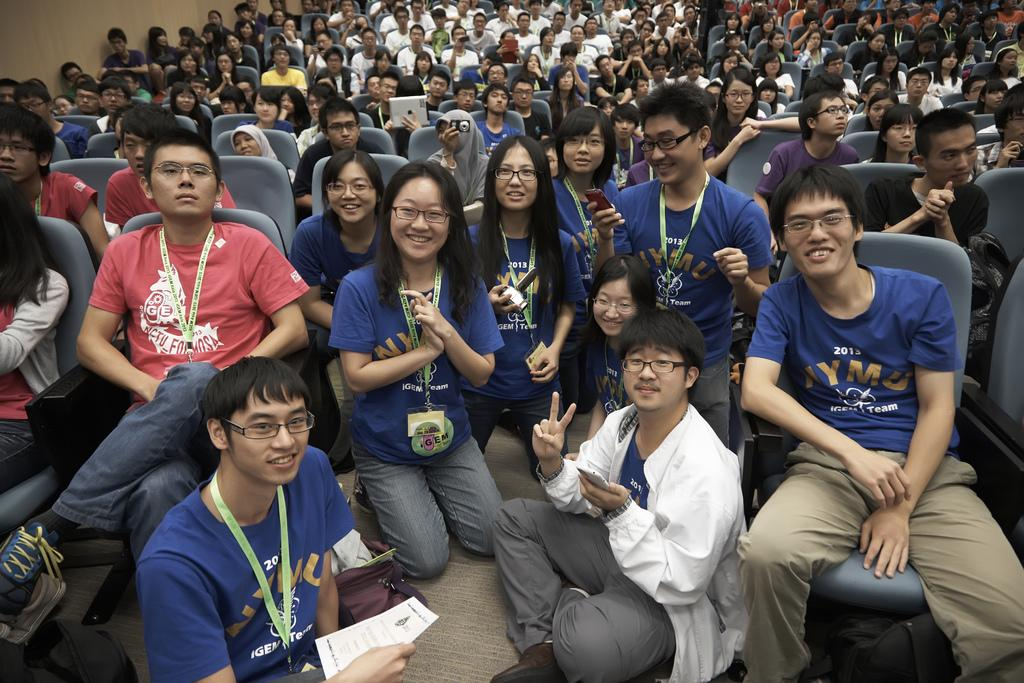What positions are the people in the image taking? There are people sitting on chairs and on the floor in the image. Can you describe the seating arrangement in the image? The people are sitting in two different positions: on chairs and on the floor. What type of wine is being served to the grandmother in the image? There is no grandmother or wine present in the image. 